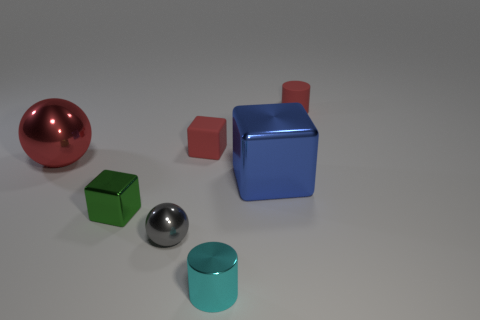Subtract all large blue metal blocks. How many blocks are left? 2 Subtract all blue cubes. How many cubes are left? 2 Add 3 yellow shiny spheres. How many objects exist? 10 Subtract all cubes. How many objects are left? 4 Subtract all purple cubes. Subtract all brown cylinders. How many cubes are left? 3 Add 6 cubes. How many cubes are left? 9 Add 6 red metallic spheres. How many red metallic spheres exist? 7 Subtract 0 purple blocks. How many objects are left? 7 Subtract all balls. Subtract all red cylinders. How many objects are left? 4 